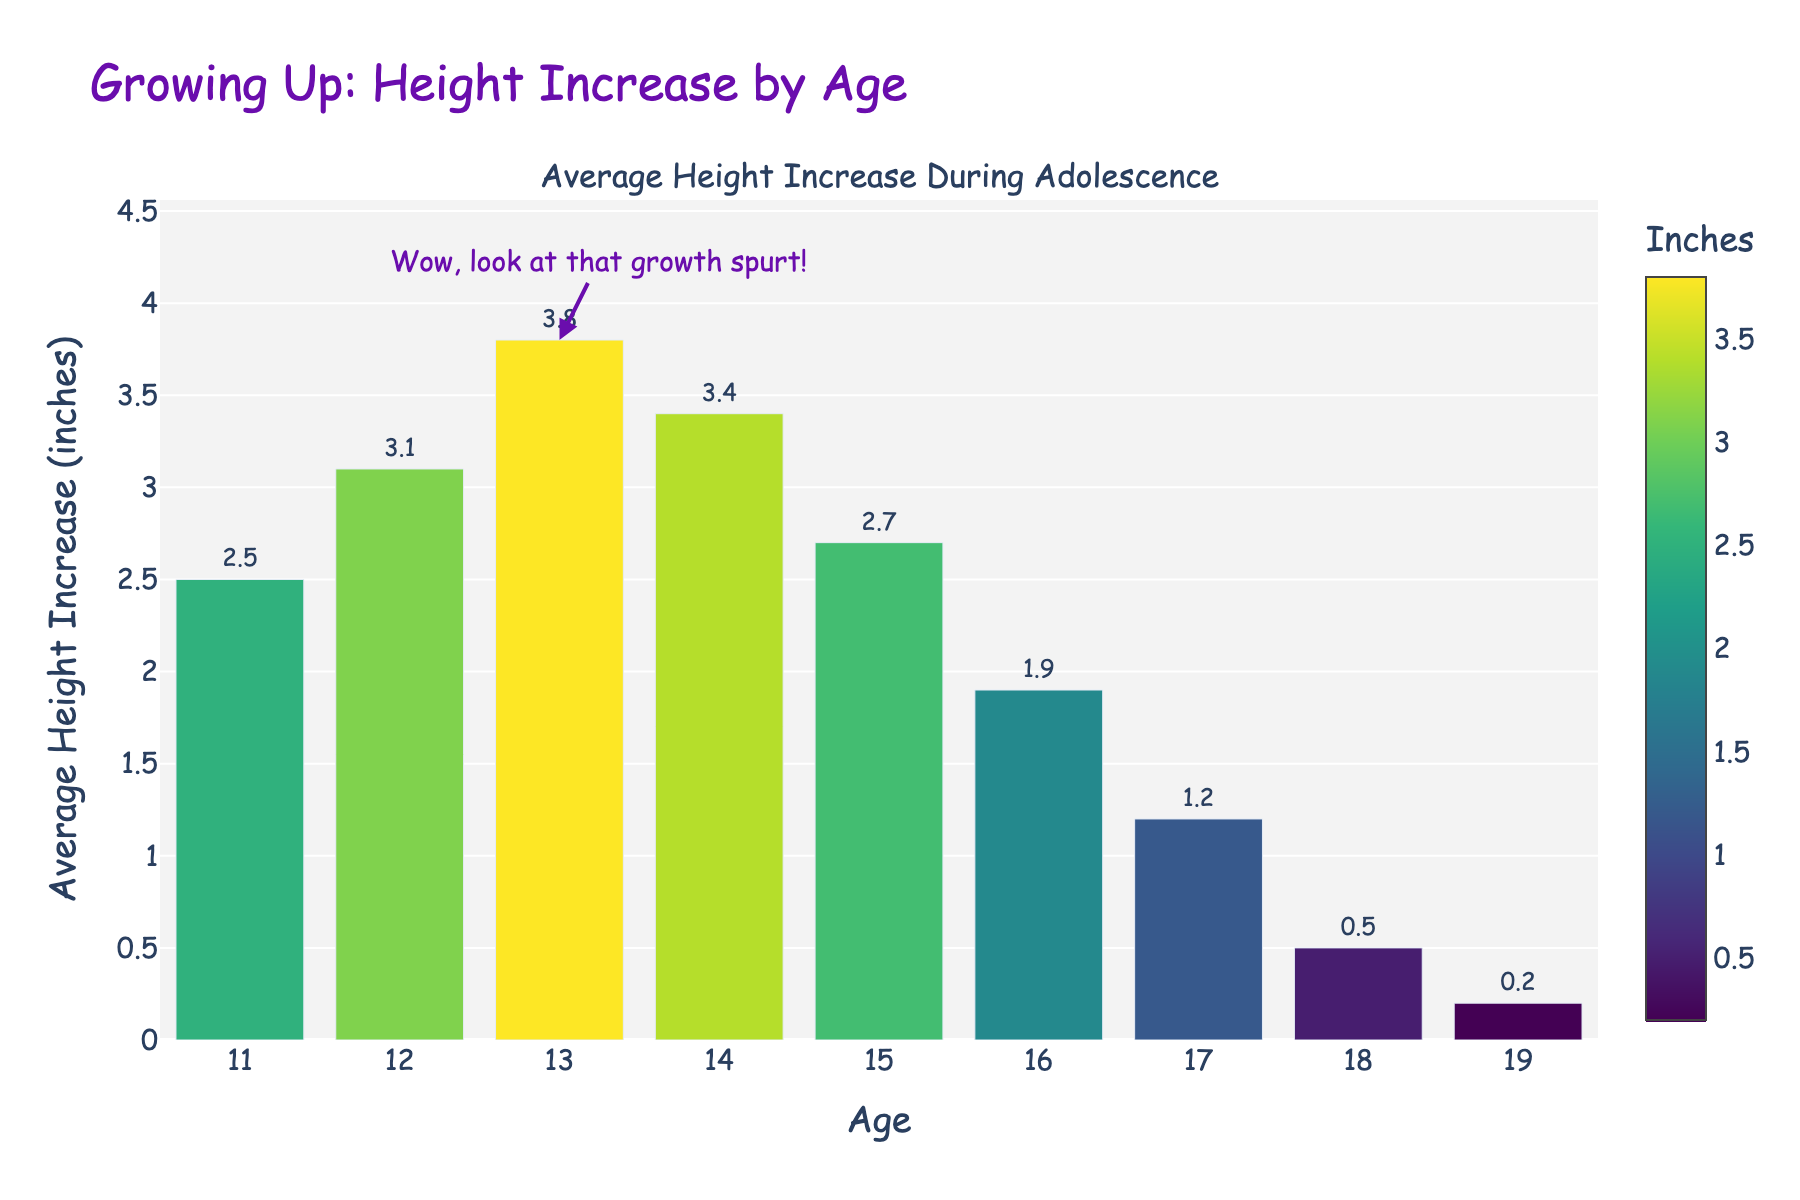What is the average height increase at age 13? Look for the bar corresponding to age 13 and note the value represented by the bar height.
Answer: 3.8 inches At what age does the maximum average height increase occur? Identify the age with the tallest bar.
Answer: 13 years How many inches does the average height increase by between the ages of 11 and 14? Add the height increase values for ages 11, 12, 13, and 14 (2.5 + 3.1 + 3.8 + 3.4).
Answer: 12.8 inches What is the difference in average height increase between ages 12 and 16? Subtract the height increase at age 16 from the height increase at age 12 (3.1 - 1.9).
Answer: 1.2 inches Which age shows the smallest average height increase? Look for the age with the shortest bar.
Answer: 19 years How does the average height increase at age 14 compare to age 18? Compare the heights of the bars for ages 14 and 18.
Answer: Age 14 is higher What is the trend in average height increase from age 15 to age 19? Observe the bars from age 15 to age 19 for any increasing or decreasing pattern.
Answer: Decreasing At what ages does the average height increase exceed 3 inches? Identify the ages where the bar height is greater than 3 inches.
Answer: 12, 13, 14 years What visual element indicates where the biggest growth spurt occurs? Look for any additional visual markers or annotations on the chart (e.g., text or arrows) highlighting the significant increase.
Answer: An annotation with "Wow, look at that growth spurt!" If the total height increase from ages 11 to 19 is considered, what is the average height increase per year? Calculate the total height increase from ages 11 to 19 and divide by the number of years (sum of all height increases divided by 9).
Answer: 1.9 inches 